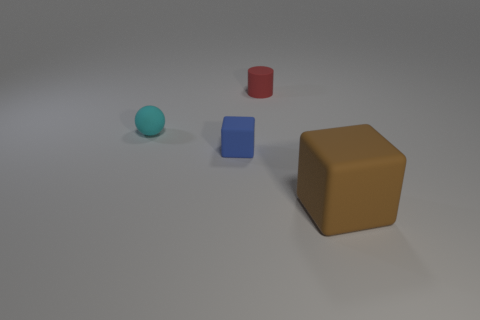What number of big things are the same color as the sphere?
Your answer should be very brief. 0. There is a cyan rubber thing that is the same size as the blue thing; what shape is it?
Ensure brevity in your answer.  Sphere. Are there any small matte spheres on the right side of the tiny cyan thing?
Ensure brevity in your answer.  No. Does the cylinder have the same size as the blue thing?
Offer a very short reply. Yes. There is a object that is on the right side of the cylinder; what shape is it?
Give a very brief answer. Cube. Is there a gray shiny cube of the same size as the cylinder?
Provide a succinct answer. No. What is the material of the red thing that is the same size as the blue object?
Provide a succinct answer. Rubber. How big is the rubber block behind the large rubber object?
Keep it short and to the point. Small. The red matte thing has what size?
Your answer should be very brief. Small. Do the blue block and the object that is to the right of the matte cylinder have the same size?
Keep it short and to the point. No. 